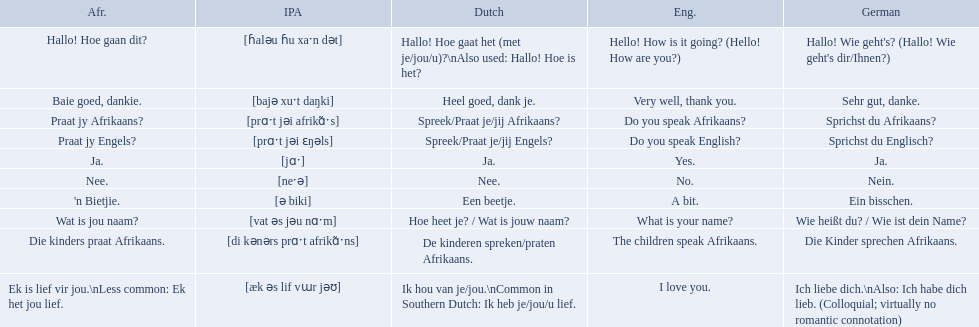What are the afrikaans phrases? Hallo! Hoe gaan dit?, Baie goed, dankie., Praat jy Afrikaans?, Praat jy Engels?, Ja., Nee., 'n Bietjie., Wat is jou naam?, Die kinders praat Afrikaans., Ek is lief vir jou.\nLess common: Ek het jou lief. For die kinders praat afrikaans, what are the translations? De kinderen spreken/praten Afrikaans., The children speak Afrikaans., Die Kinder sprechen Afrikaans. Which one is the german translation? Die Kinder sprechen Afrikaans. I'm looking to parse the entire table for insights. Could you assist me with that? {'header': ['Afr.', 'IPA', 'Dutch', 'Eng.', 'German'], 'rows': [['Hallo! Hoe gaan dit?', '[ɦaləu ɦu xaˑn dət]', 'Hallo! Hoe gaat het (met je/jou/u)?\\nAlso used: Hallo! Hoe is het?', 'Hello! How is it going? (Hello! How are you?)', "Hallo! Wie geht's? (Hallo! Wie geht's dir/Ihnen?)"], ['Baie goed, dankie.', '[bajə xuˑt daŋki]', 'Heel goed, dank je.', 'Very well, thank you.', 'Sehr gut, danke.'], ['Praat jy Afrikaans?', '[prɑˑt jəi afrikɑ̃ˑs]', 'Spreek/Praat je/jij Afrikaans?', 'Do you speak Afrikaans?', 'Sprichst du Afrikaans?'], ['Praat jy Engels?', '[prɑˑt jəi ɛŋəls]', 'Spreek/Praat je/jij Engels?', 'Do you speak English?', 'Sprichst du Englisch?'], ['Ja.', '[jɑˑ]', 'Ja.', 'Yes.', 'Ja.'], ['Nee.', '[neˑə]', 'Nee.', 'No.', 'Nein.'], ["'n Bietjie.", '[ə biki]', 'Een beetje.', 'A bit.', 'Ein bisschen.'], ['Wat is jou naam?', '[vat əs jəu nɑˑm]', 'Hoe heet je? / Wat is jouw naam?', 'What is your name?', 'Wie heißt du? / Wie ist dein Name?'], ['Die kinders praat Afrikaans.', '[di kənərs prɑˑt afrikɑ̃ˑns]', 'De kinderen spreken/praten Afrikaans.', 'The children speak Afrikaans.', 'Die Kinder sprechen Afrikaans.'], ['Ek is lief vir jou.\\nLess common: Ek het jou lief.', '[æk əs lif vɯr jəʊ]', 'Ik hou van je/jou.\\nCommon in Southern Dutch: Ik heb je/jou/u lief.', 'I love you.', 'Ich liebe dich.\\nAlso: Ich habe dich lieb. (Colloquial; virtually no romantic connotation)']]} How would you say the phrase the children speak afrikaans in afrikaans? Die kinders praat Afrikaans. How would you say the previous phrase in german? Die Kinder sprechen Afrikaans. What are the listed afrikaans phrases? Hallo! Hoe gaan dit?, Baie goed, dankie., Praat jy Afrikaans?, Praat jy Engels?, Ja., Nee., 'n Bietjie., Wat is jou naam?, Die kinders praat Afrikaans., Ek is lief vir jou.\nLess common: Ek het jou lief. Which is die kinders praat afrikaans? Die kinders praat Afrikaans. What is its german translation? Die Kinder sprechen Afrikaans. How do you say do you speak english in german? Sprichst du Englisch?. What about do you speak afrikaanss? in afrikaans? Praat jy Afrikaans?. In german how do you say do you speak afrikaans? Sprichst du Afrikaans?. How do you say it in afrikaans? Praat jy Afrikaans?. What are all of the afrikaans phrases in the list? Hallo! Hoe gaan dit?, Baie goed, dankie., Praat jy Afrikaans?, Praat jy Engels?, Ja., Nee., 'n Bietjie., Wat is jou naam?, Die kinders praat Afrikaans., Ek is lief vir jou.\nLess common: Ek het jou lief. What is the english translation of each phrase? Hello! How is it going? (Hello! How are you?), Very well, thank you., Do you speak Afrikaans?, Do you speak English?, Yes., No., A bit., What is your name?, The children speak Afrikaans., I love you. And which afrikaans phrase translated to do you speak afrikaans? Praat jy Afrikaans?. 